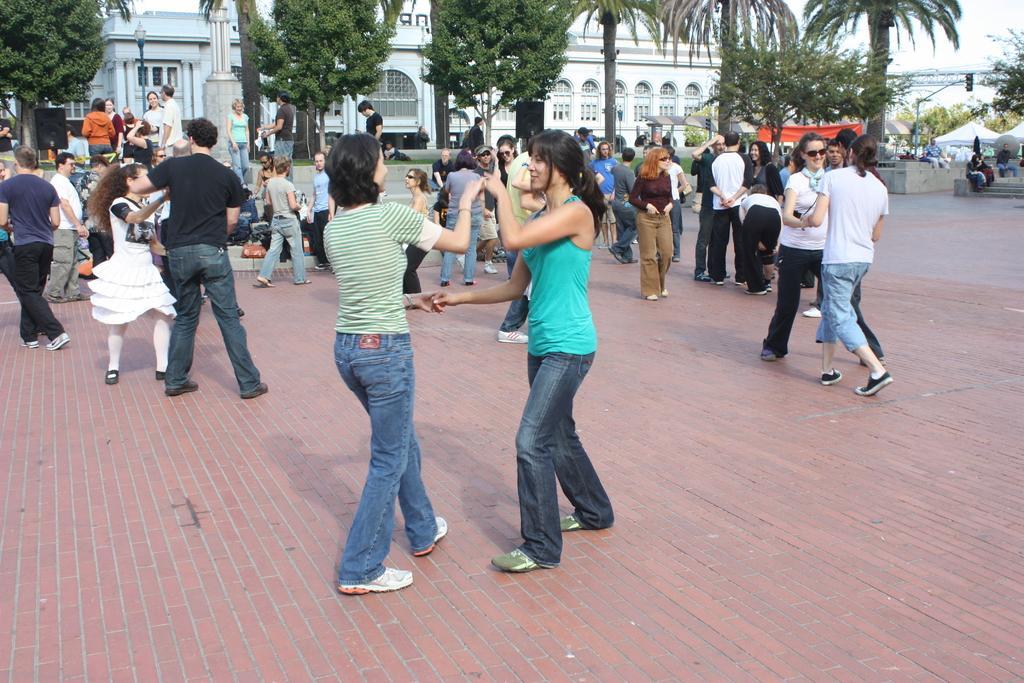In one or two sentences, can you explain what this image depicts? As we can see in the image, there are group of people dancing and there are few trees. In the background there is a white color building. 